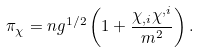Convert formula to latex. <formula><loc_0><loc_0><loc_500><loc_500>\pi _ { \chi } = n g ^ { 1 / 2 } \left ( 1 + \frac { \chi _ { , i } \chi ^ { , i } } { m ^ { 2 } } \right ) .</formula> 